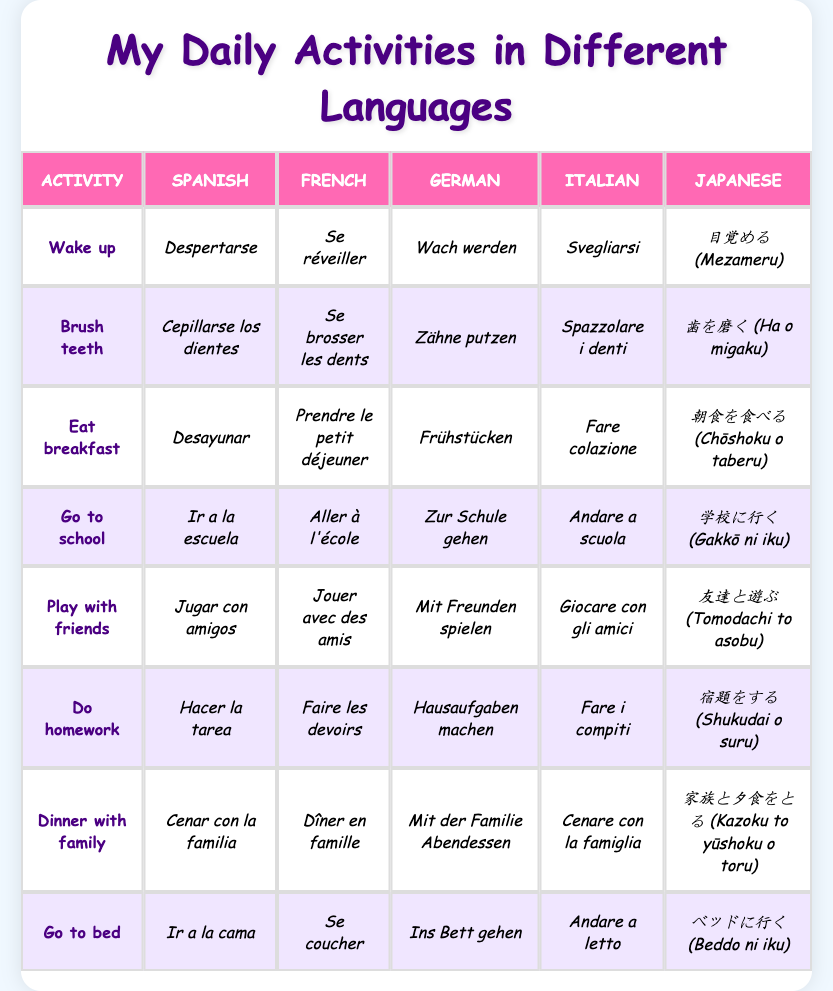What is "Eat breakfast" in Spanish? The table has a column for Spanish translations and under the "Eat breakfast" row, the corresponding translation is listed. The Spanish translation is "Desayunar."
Answer: Desayunar How do you say "Go to school" in German? By checking the table, we can see that in the row for "Go to school," the German translation is given in the German column. It says "Zur Schule gehen."
Answer: Zur Schule gehen Is "Dinner with family" translated as "Dîner en famille" in French? Referring to the table, the translation for "Dinner with family" in the French column is listed as "Dîner en famille." Since it matches the statement, the answer is true.
Answer: Yes How many different languages are used for translations? The table includes six different languages: Spanish, French, German, Italian, Japanese, and English. To find the total, we can simply count the language columns. The total is 5 languages listed under activities.
Answer: 5 Which activity has the same beginning letter in both Spanish and Italian? By examining the table, we look at the Spanish and Italian translations. The activity "Go to school" in Spanish is "Ir a la escuela" and in Italian is "Andare a scuola." Both begin with the letter 'I.'
Answer: Go to school What is the average number of words in the translations for each activity? Each translation is counted for every language for the activities. Summing up the word counts would be: 3 (Despertarse) + 5 (Se réveiller) + 2 (Wach werden) + 3 (Svegliarsi) + 4 (Mezameru) for "Wake up" and similarly for other activities. After calculating for all 8 activities, we find the total word count and divide by 8 for the average. The average is found to be around 5.
Answer: 5 For which activity does the Japanese translation have the most characters? Checking each row in the table, we can evaluate the character count for the Japanese translations. The longest one is for "Dinner with family," which is "家族と夕食をとる (Kazoku to yūshoku o toru)" having 12 characters.
Answer: Dinner with family Are there any activities that have the same translation in both Spanish and Italian? To determine this, we cross-reference all activity translations in the Spanish and Italian columns. By doing this, we find no translations are the same. Therefore, the answer is no.
Answer: No 